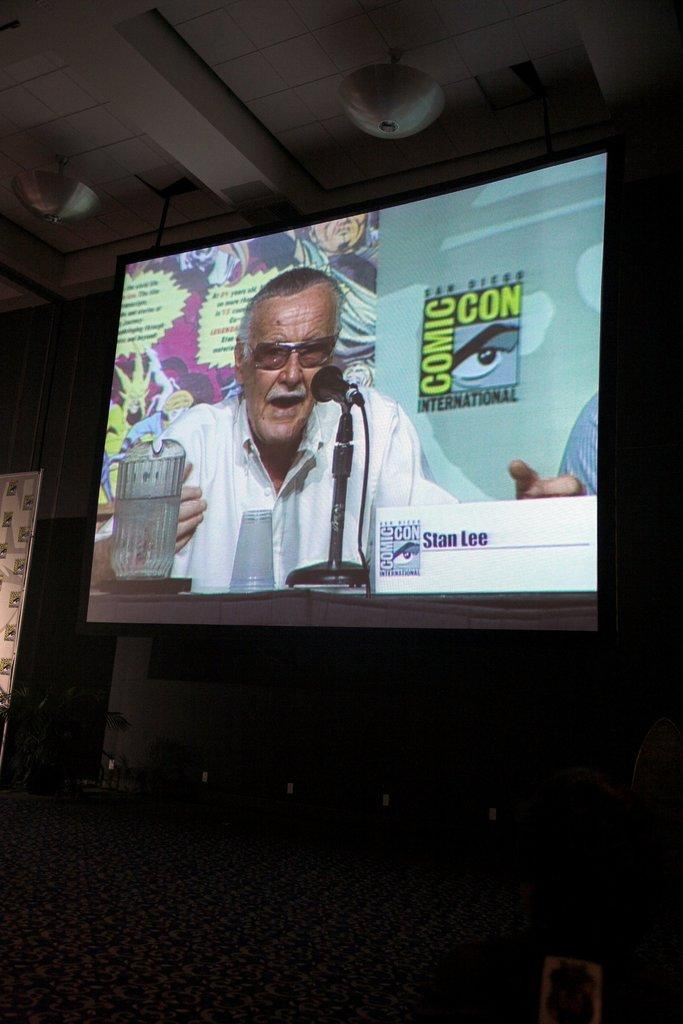Provide a one-sentence caption for the provided image. The tv screen shows a man being interviewed at  comic con. 